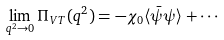Convert formula to latex. <formula><loc_0><loc_0><loc_500><loc_500>\lim _ { q ^ { 2 } \rightarrow 0 } \Pi _ { V T } ( q ^ { 2 } ) = - \chi _ { 0 } \langle { \bar { \psi } } \psi \rangle + \cdots</formula> 